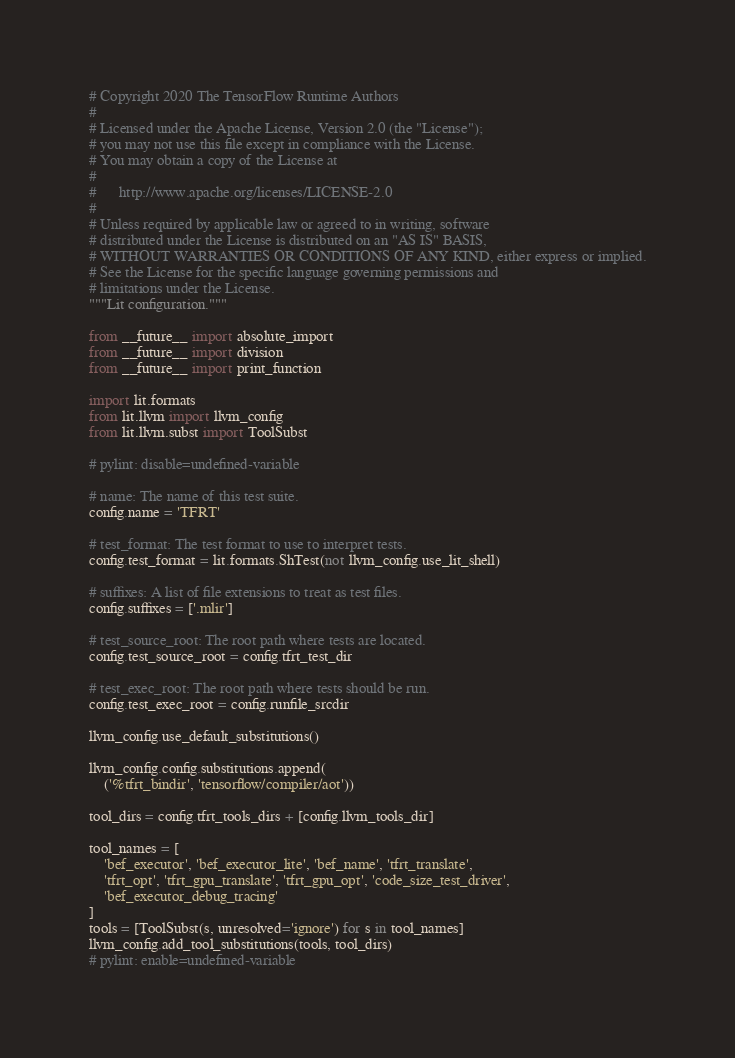Convert code to text. <code><loc_0><loc_0><loc_500><loc_500><_Python_># Copyright 2020 The TensorFlow Runtime Authors
#
# Licensed under the Apache License, Version 2.0 (the "License");
# you may not use this file except in compliance with the License.
# You may obtain a copy of the License at
#
#      http://www.apache.org/licenses/LICENSE-2.0
#
# Unless required by applicable law or agreed to in writing, software
# distributed under the License is distributed on an "AS IS" BASIS,
# WITHOUT WARRANTIES OR CONDITIONS OF ANY KIND, either express or implied.
# See the License for the specific language governing permissions and
# limitations under the License.
"""Lit configuration."""

from __future__ import absolute_import
from __future__ import division
from __future__ import print_function

import lit.formats
from lit.llvm import llvm_config
from lit.llvm.subst import ToolSubst

# pylint: disable=undefined-variable

# name: The name of this test suite.
config.name = 'TFRT'

# test_format: The test format to use to interpret tests.
config.test_format = lit.formats.ShTest(not llvm_config.use_lit_shell)

# suffixes: A list of file extensions to treat as test files.
config.suffixes = ['.mlir']

# test_source_root: The root path where tests are located.
config.test_source_root = config.tfrt_test_dir

# test_exec_root: The root path where tests should be run.
config.test_exec_root = config.runfile_srcdir

llvm_config.use_default_substitutions()

llvm_config.config.substitutions.append(
    ('%tfrt_bindir', 'tensorflow/compiler/aot'))

tool_dirs = config.tfrt_tools_dirs + [config.llvm_tools_dir]

tool_names = [
    'bef_executor', 'bef_executor_lite', 'bef_name', 'tfrt_translate',
    'tfrt_opt', 'tfrt_gpu_translate', 'tfrt_gpu_opt', 'code_size_test_driver',
    'bef_executor_debug_tracing'
]
tools = [ToolSubst(s, unresolved='ignore') for s in tool_names]
llvm_config.add_tool_substitutions(tools, tool_dirs)
# pylint: enable=undefined-variable
</code> 